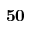<formula> <loc_0><loc_0><loc_500><loc_500>5 0</formula> 